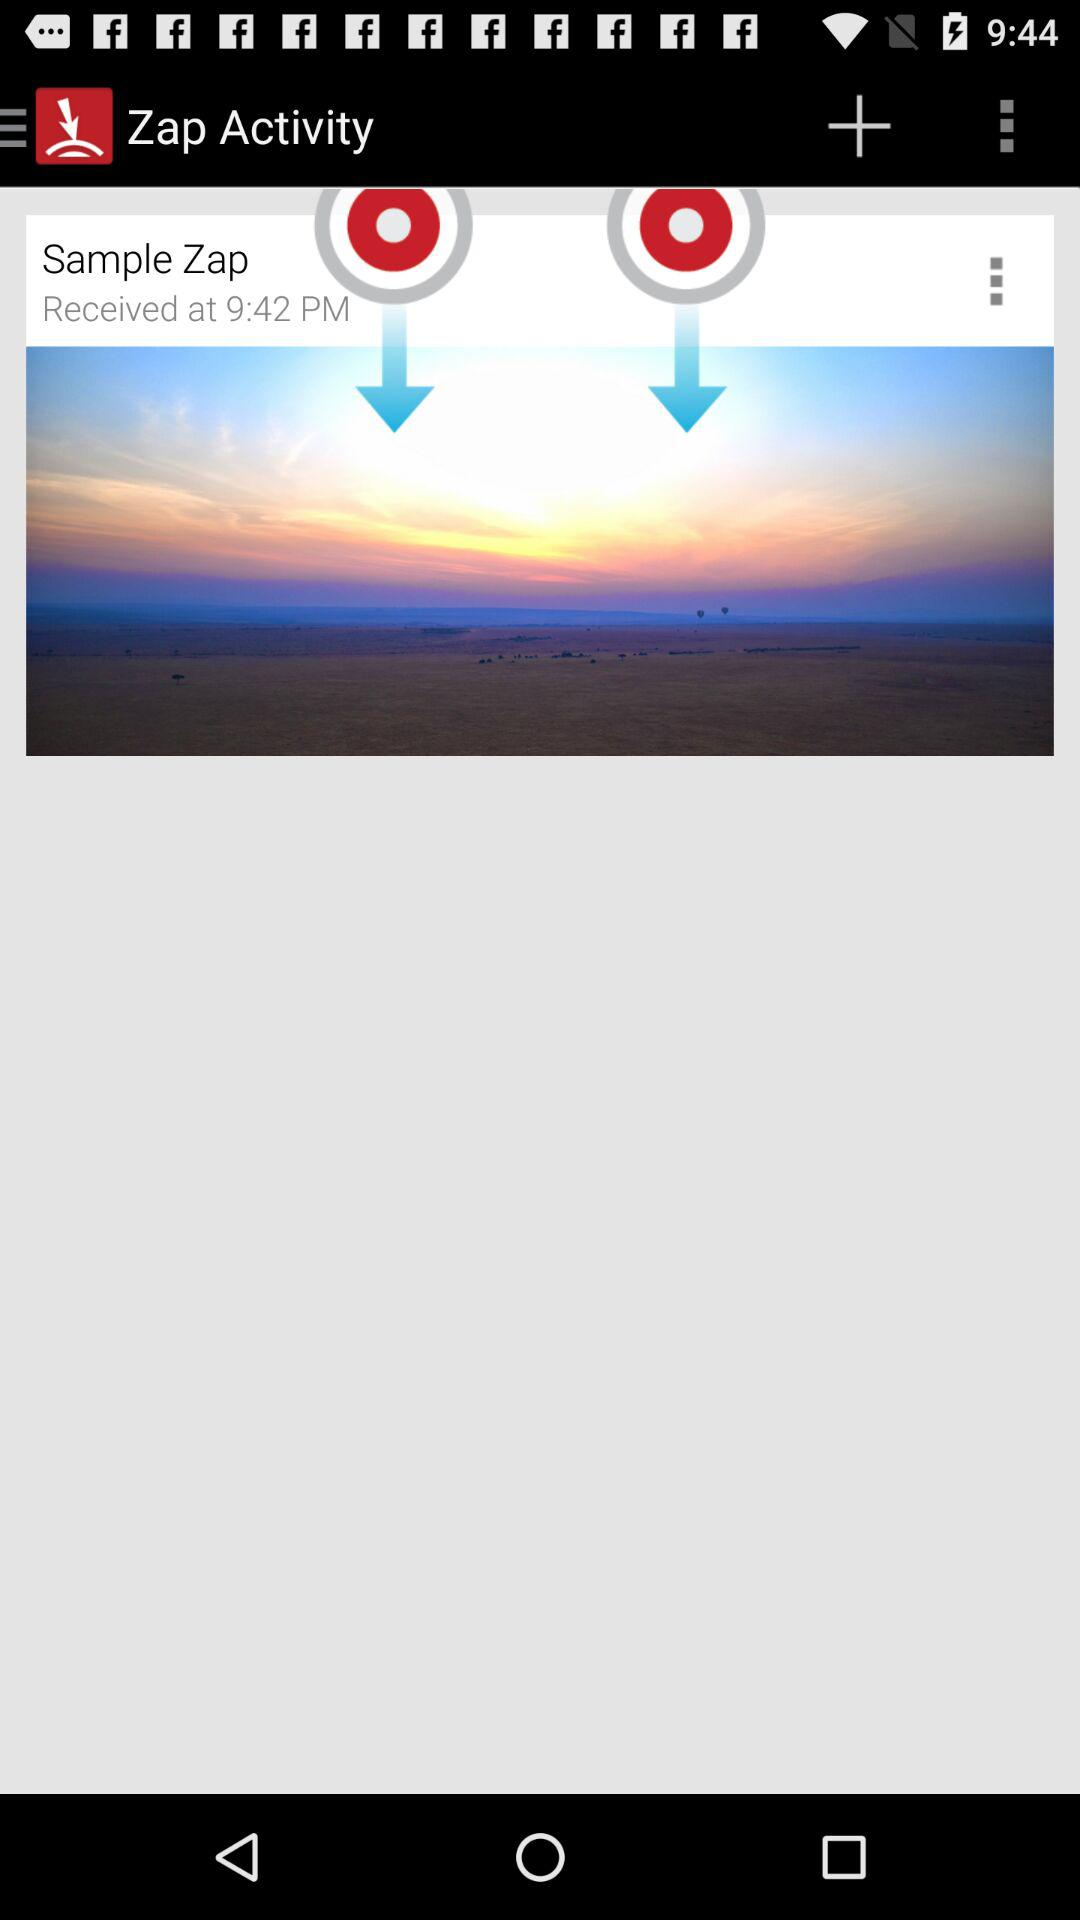When was the sample zap received? The sample zap was received at 9:42 p.m. 